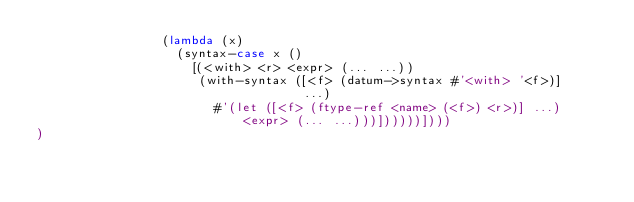<code> <loc_0><loc_0><loc_500><loc_500><_Scheme_>                 (lambda (x)
                   (syntax-case x ()
                     [(<with> <r> <expr> (... ...))
                      (with-syntax ([<f> (datum->syntax #'<with> '<f>)]
                                    ...)
                        #'(let ([<f> (ftype-ref <name> (<f>) <r>)] ...)
                            <expr> (... ...)))])))))])))
)

</code> 